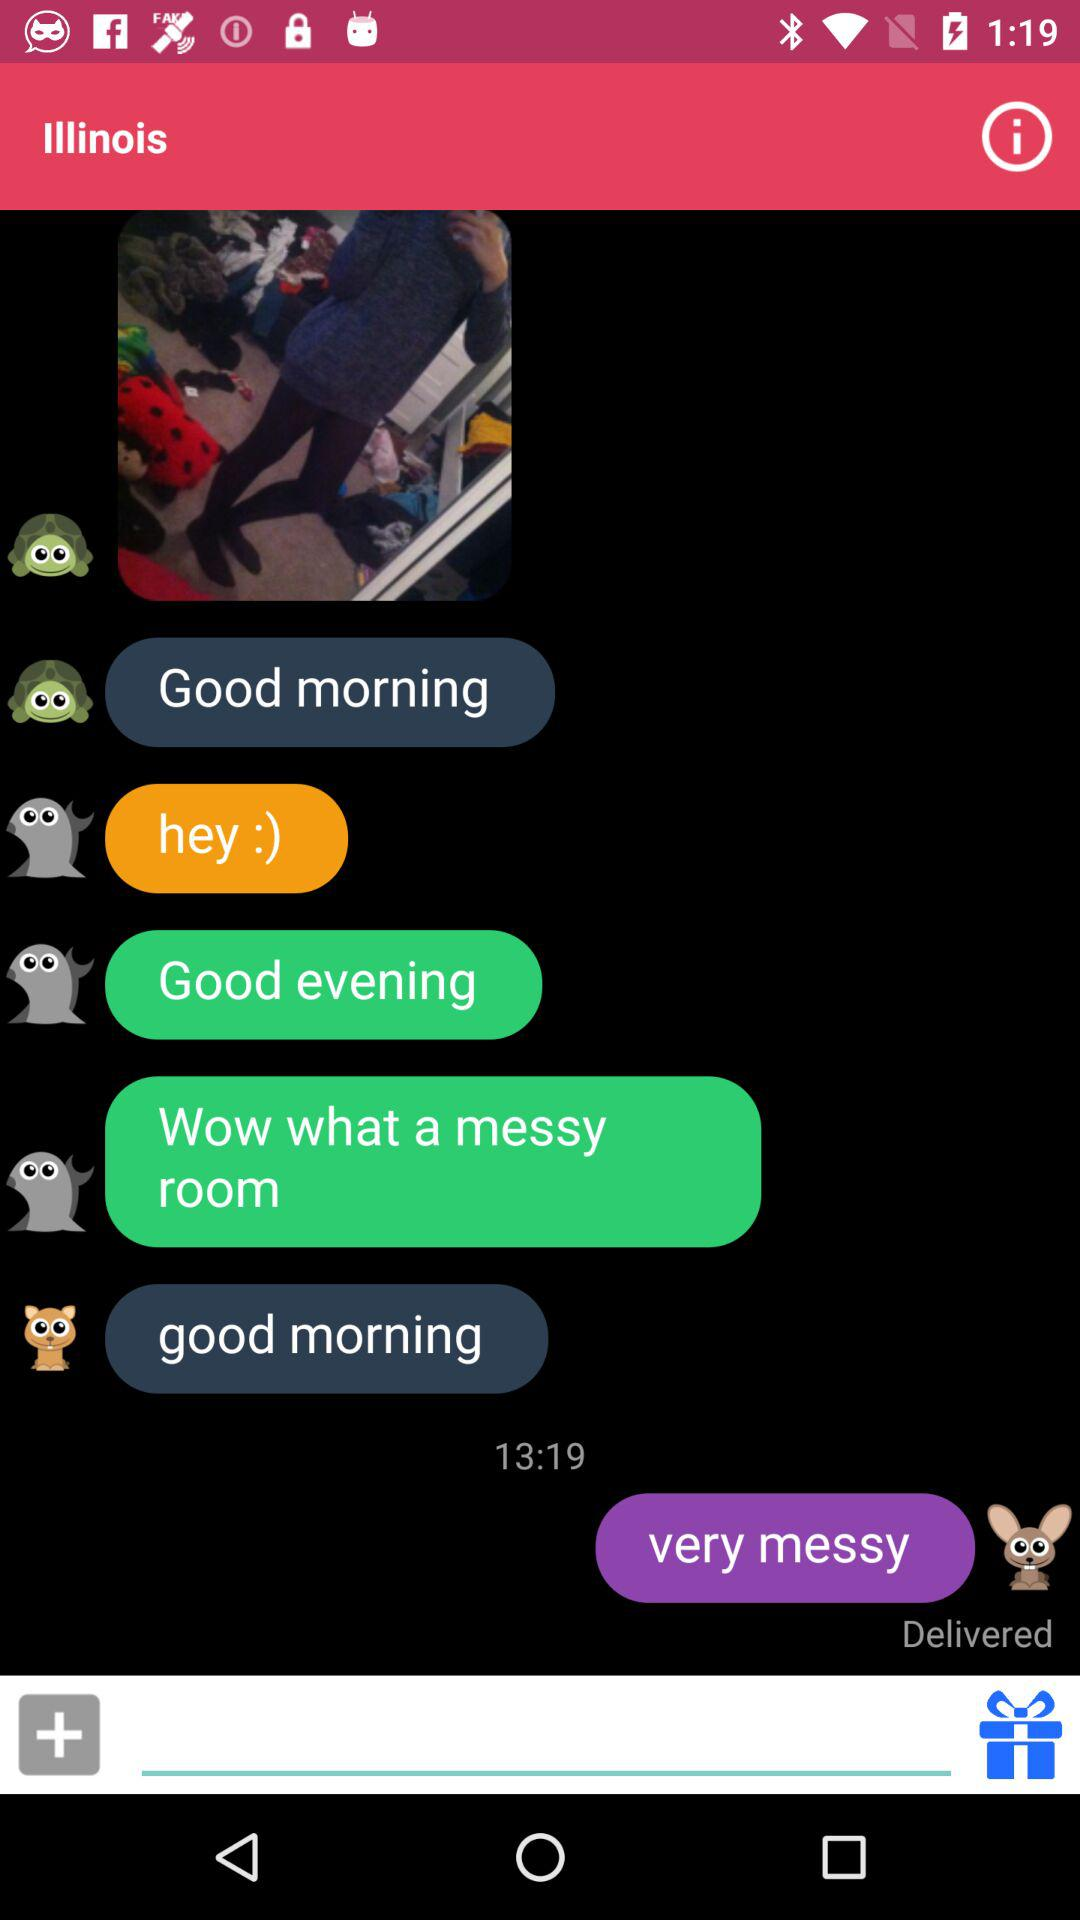When was the last message sent? The last message was sent at 13:19. 